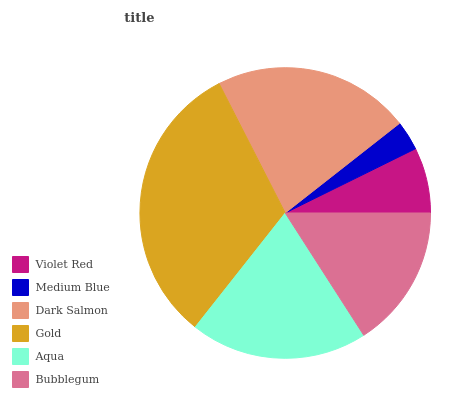Is Medium Blue the minimum?
Answer yes or no. Yes. Is Gold the maximum?
Answer yes or no. Yes. Is Dark Salmon the minimum?
Answer yes or no. No. Is Dark Salmon the maximum?
Answer yes or no. No. Is Dark Salmon greater than Medium Blue?
Answer yes or no. Yes. Is Medium Blue less than Dark Salmon?
Answer yes or no. Yes. Is Medium Blue greater than Dark Salmon?
Answer yes or no. No. Is Dark Salmon less than Medium Blue?
Answer yes or no. No. Is Aqua the high median?
Answer yes or no. Yes. Is Bubblegum the low median?
Answer yes or no. Yes. Is Dark Salmon the high median?
Answer yes or no. No. Is Aqua the low median?
Answer yes or no. No. 